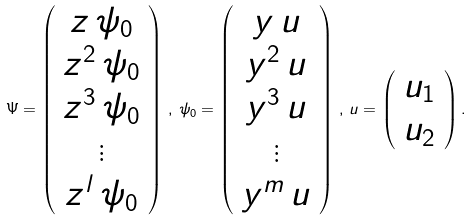<formula> <loc_0><loc_0><loc_500><loc_500>\Psi = \left ( \begin{array} { c } z \, \psi _ { 0 } \\ z ^ { 2 } \, \psi _ { 0 } \\ z ^ { 3 } \, \psi _ { 0 } \\ \vdots \\ z ^ { l } \, \psi _ { 0 } \end{array} \right ) \, , \, \psi _ { 0 } = \left ( \begin{array} { c } y \, u \\ y ^ { 2 } \, u \\ y ^ { 3 } \, u \\ \vdots \\ y ^ { m } \, u \end{array} \right ) \, , \, u = \left ( \begin{array} { c } u _ { 1 } \\ u _ { 2 } \end{array} \right ) .</formula> 